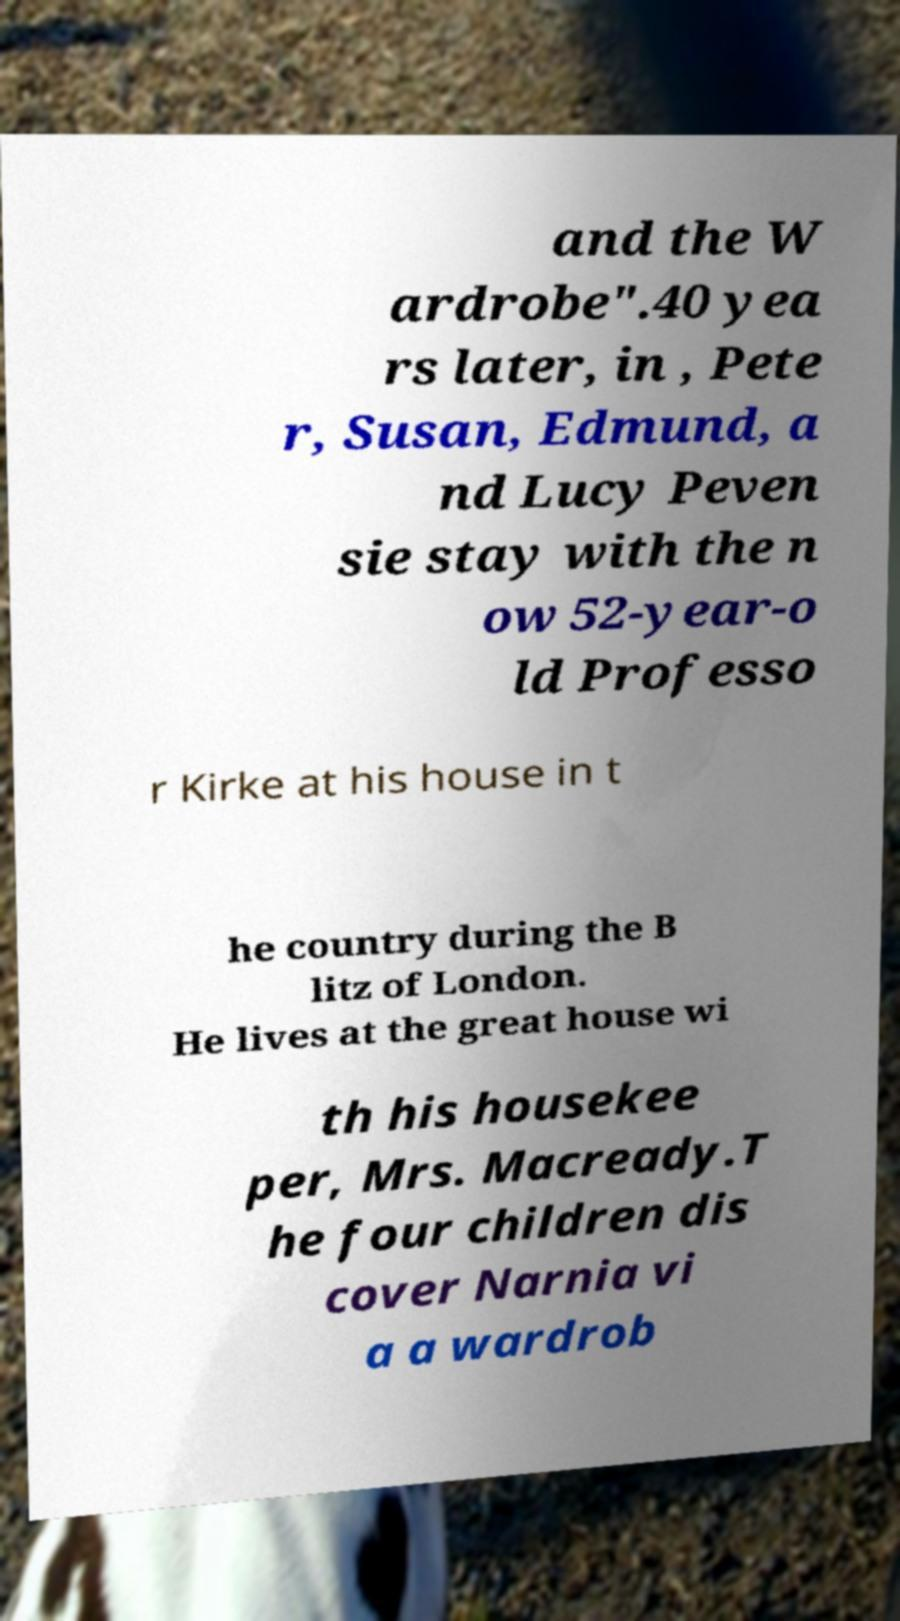Please identify and transcribe the text found in this image. and the W ardrobe".40 yea rs later, in , Pete r, Susan, Edmund, a nd Lucy Peven sie stay with the n ow 52-year-o ld Professo r Kirke at his house in t he country during the B litz of London. He lives at the great house wi th his housekee per, Mrs. Macready.T he four children dis cover Narnia vi a a wardrob 